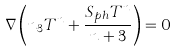<formula> <loc_0><loc_0><loc_500><loc_500>\nabla \left ( n _ { 3 } T ^ { n } + \frac { S _ { p h } T ^ { n } } { n + 3 } \right ) = 0</formula> 